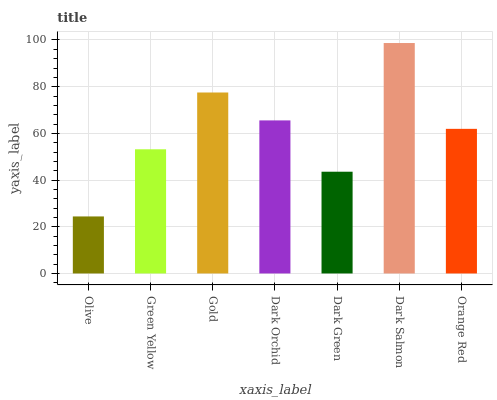Is Olive the minimum?
Answer yes or no. Yes. Is Dark Salmon the maximum?
Answer yes or no. Yes. Is Green Yellow the minimum?
Answer yes or no. No. Is Green Yellow the maximum?
Answer yes or no. No. Is Green Yellow greater than Olive?
Answer yes or no. Yes. Is Olive less than Green Yellow?
Answer yes or no. Yes. Is Olive greater than Green Yellow?
Answer yes or no. No. Is Green Yellow less than Olive?
Answer yes or no. No. Is Orange Red the high median?
Answer yes or no. Yes. Is Orange Red the low median?
Answer yes or no. Yes. Is Dark Orchid the high median?
Answer yes or no. No. Is Dark Orchid the low median?
Answer yes or no. No. 